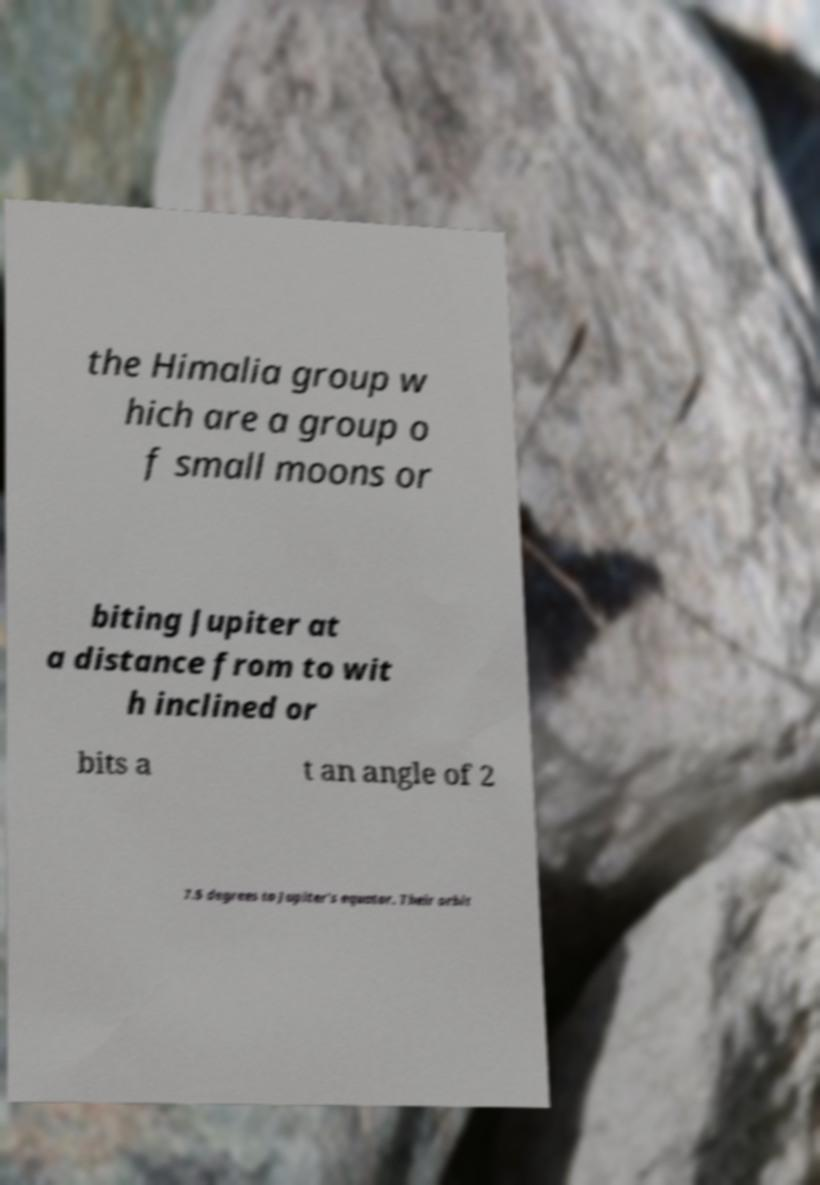What messages or text are displayed in this image? I need them in a readable, typed format. the Himalia group w hich are a group o f small moons or biting Jupiter at a distance from to wit h inclined or bits a t an angle of 2 7.5 degrees to Jupiter's equator. Their orbit 